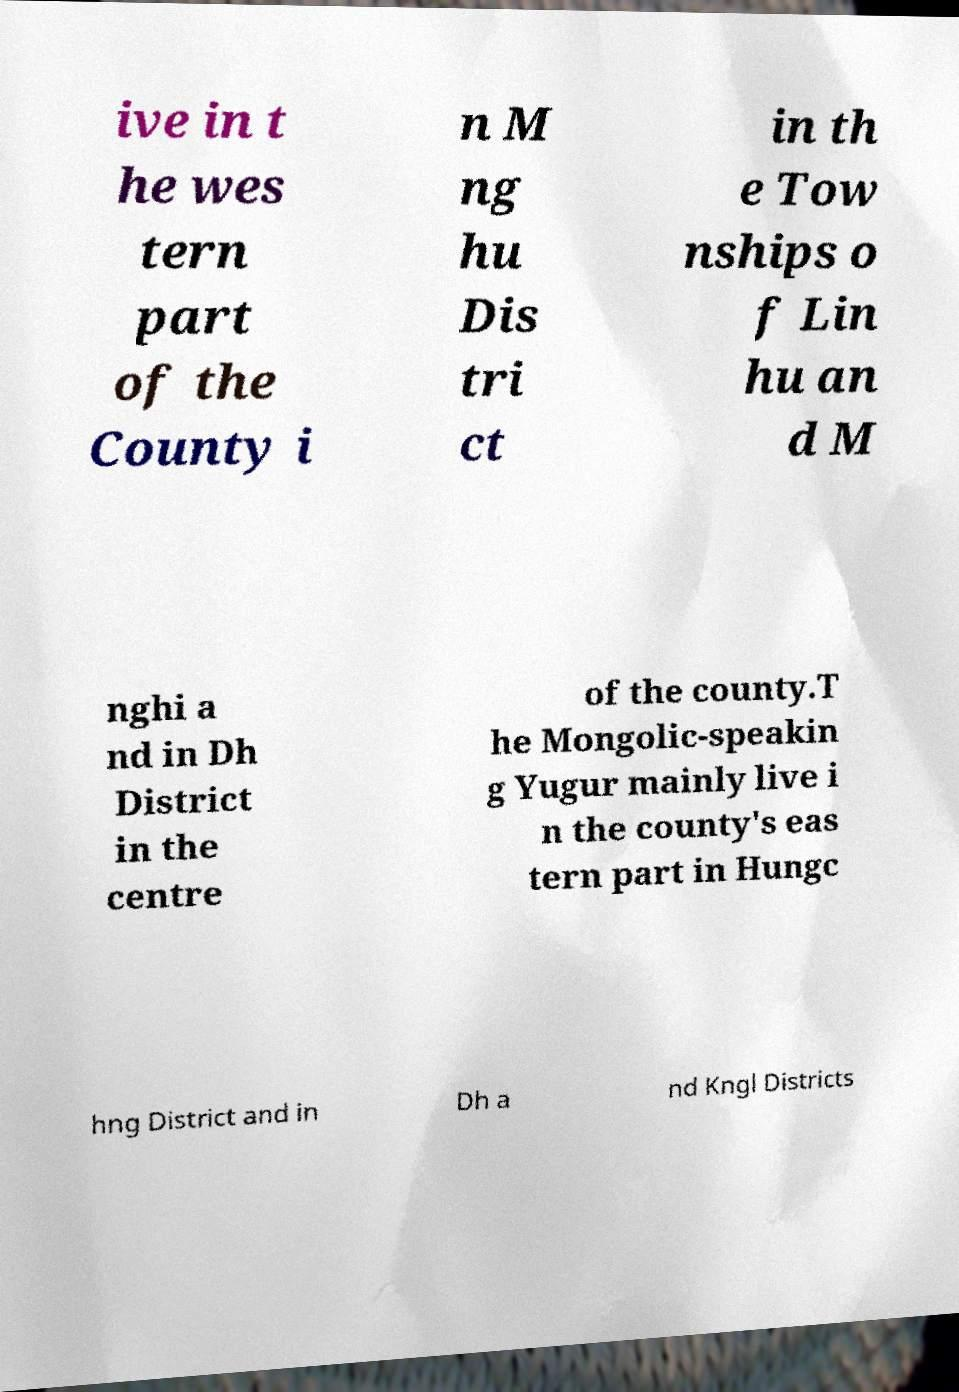Could you assist in decoding the text presented in this image and type it out clearly? ive in t he wes tern part of the County i n M ng hu Dis tri ct in th e Tow nships o f Lin hu an d M nghi a nd in Dh District in the centre of the county.T he Mongolic-speakin g Yugur mainly live i n the county's eas tern part in Hungc hng District and in Dh a nd Kngl Districts 